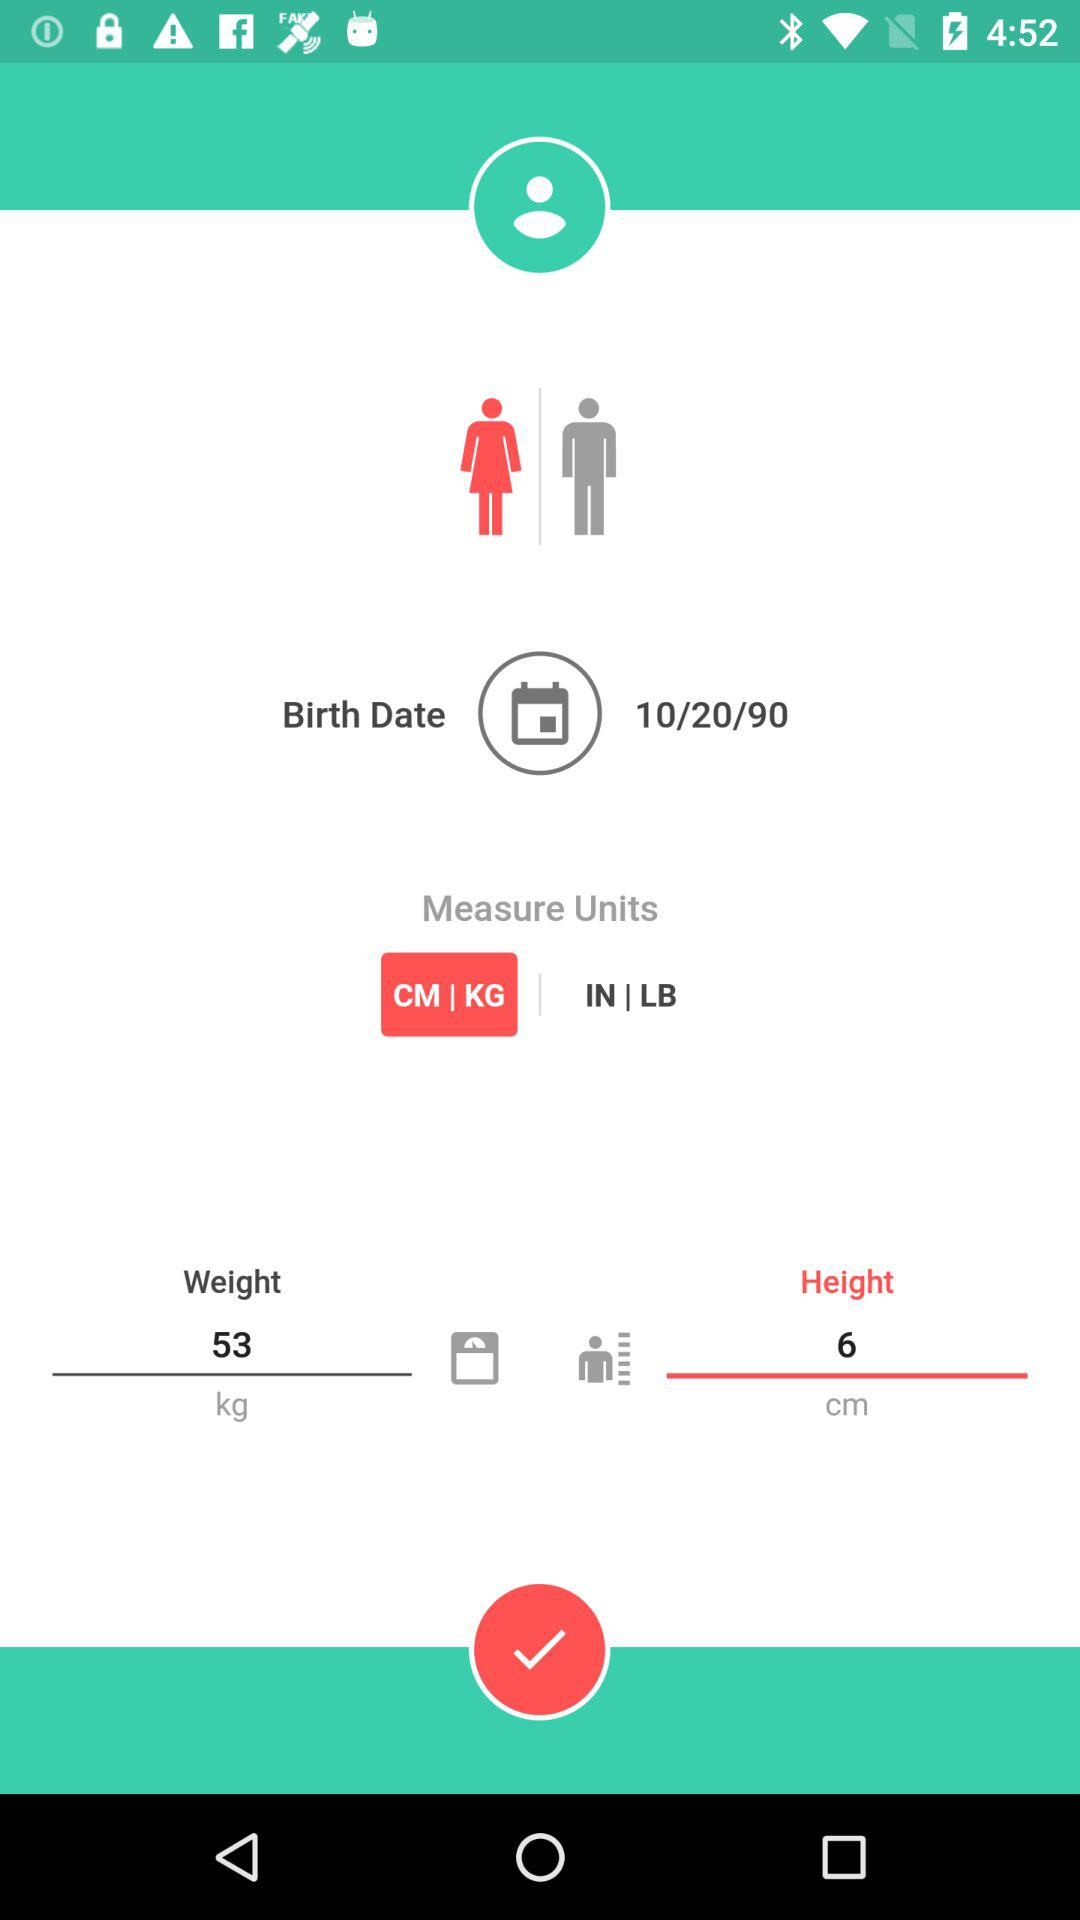What is the height? The height is 6 cm. 